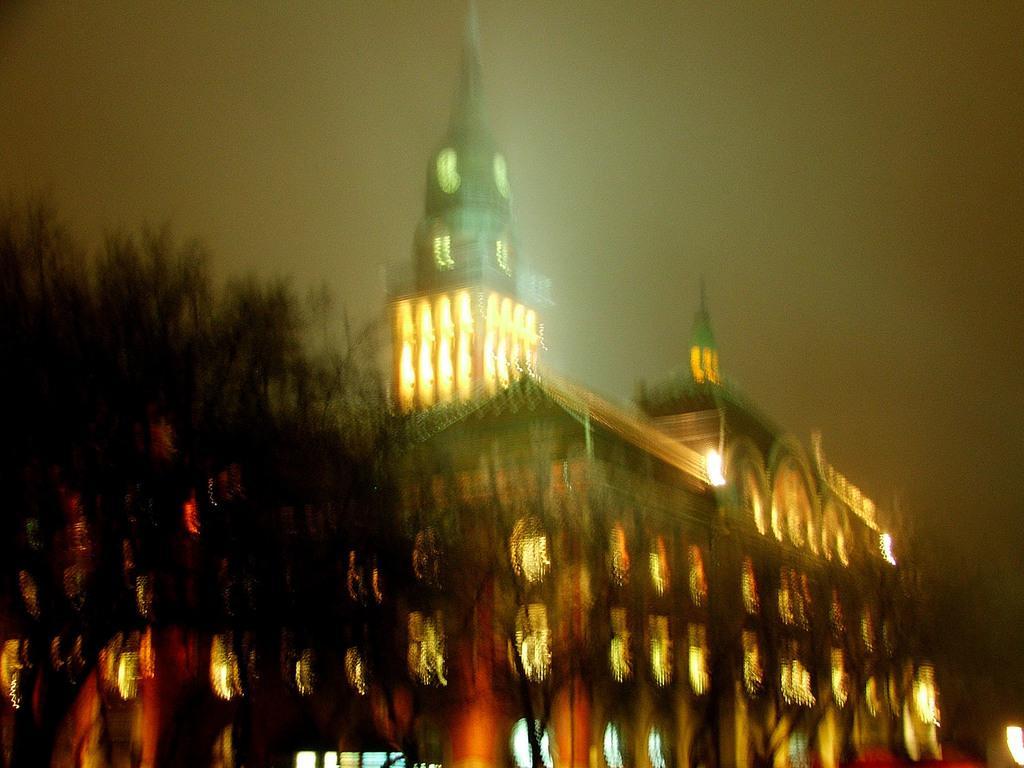Can you describe this image briefly? This picture is blur, in this picture we can see building and trees. In the background of the image we can see the sky. 